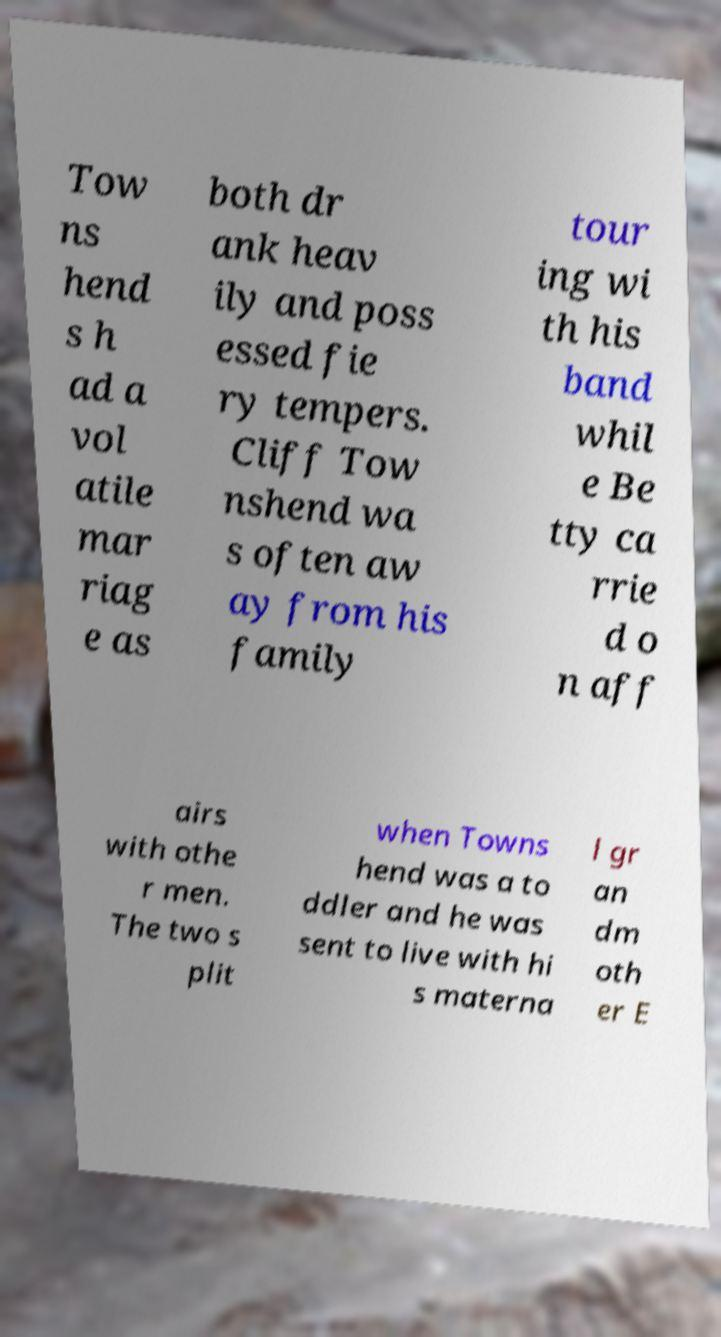Please identify and transcribe the text found in this image. Tow ns hend s h ad a vol atile mar riag e as both dr ank heav ily and poss essed fie ry tempers. Cliff Tow nshend wa s often aw ay from his family tour ing wi th his band whil e Be tty ca rrie d o n aff airs with othe r men. The two s plit when Towns hend was a to ddler and he was sent to live with hi s materna l gr an dm oth er E 